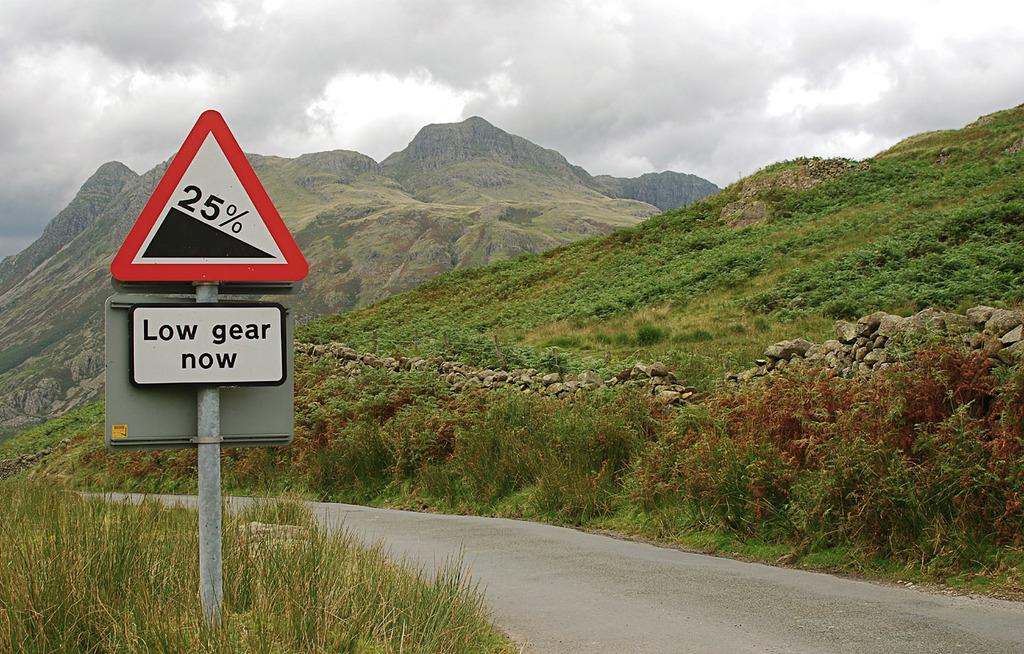<image>
Offer a succinct explanation of the picture presented. A sign indicates that an upcoming section of road has a 25% grade. 